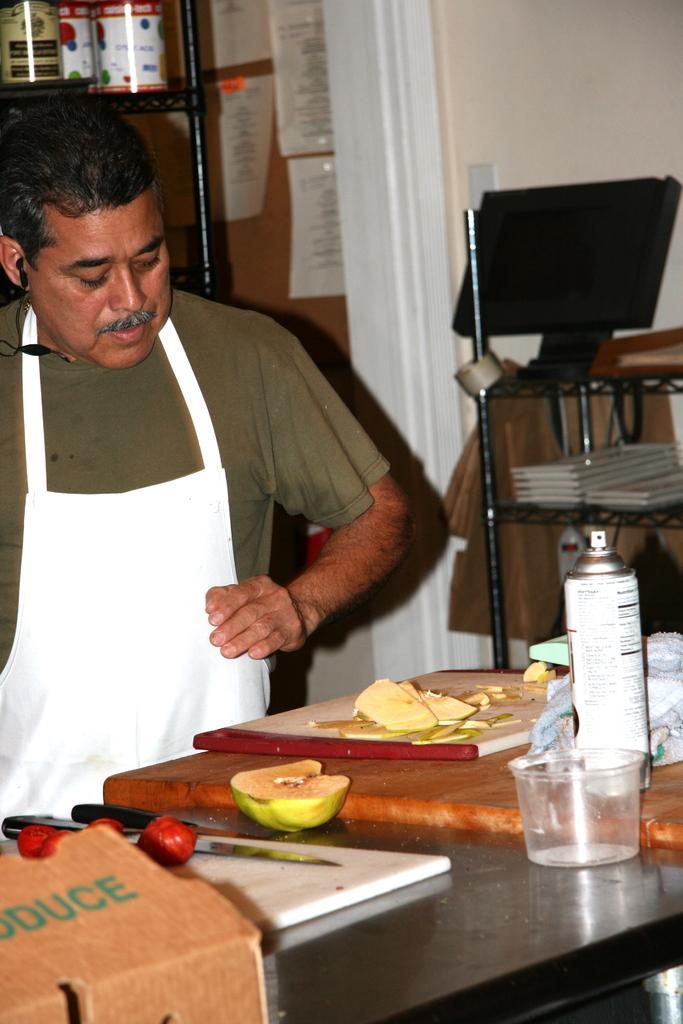Please provide a concise description of this image. In this image i can a man seeing the fruit. There is a cart board, a fruit,a knife,a bottle,a glass on the table. At the back ground there are few book in the rack,there is a desktop on the rack,there is a wall some papers attached to the wall. 